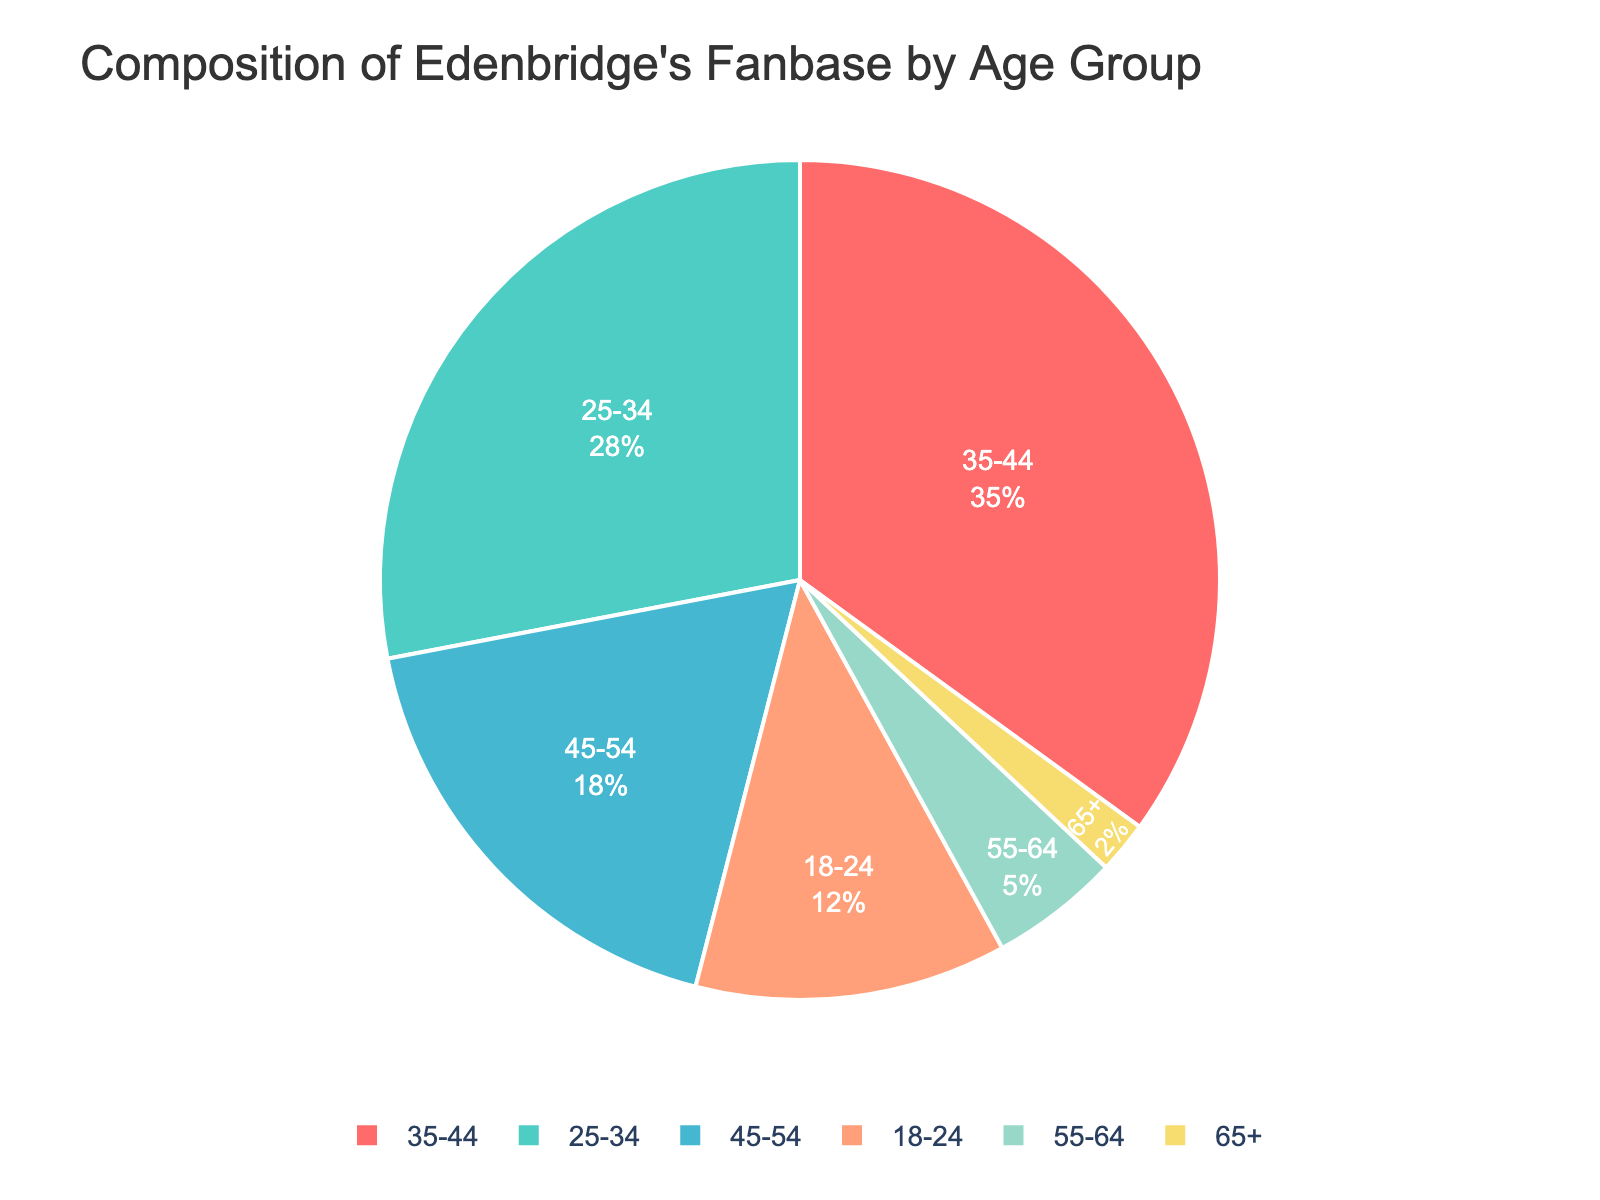What's the largest age group in Edenbridge's fanbase? Look at the pie chart and identify the sector with the largest percentage. The age group 35-44 has the largest percentage of 35%
Answer: Age group 35-44 What's the combined percentage of fans aged 45-64? Add the percentages for the age groups 45-54 and 55-64. Thus, 18% + 5% = 23%
Answer: 23% Which age group has the smallest representation in the fanbase? Look for the smallest sector in the pie chart representing the lowest percentage. The age group 65+ has the smallest percentage of 2%
Answer: Age group 65+ Is the percentage of the fanbase aged 25-34 higher than that of the 45-54 age group? Compare the percentages of the two age groups: 25-34 has 28%, and 45-54 has 18%. Since 28% > 18%, the 25-34 group is higher
Answer: Yes What's the difference in the percentage of fans between the 18-24 and the 55-64 age groups? Calculate the difference by subtracting the smaller percentage from the larger one: 12% (18-24) - 5% (55-64) = 7%
Answer: 7% What proportion of the fanbase is younger than 35? Add the percentages for the age groups 18-24 and 25-34: 12% + 28% = 40%
Answer: 40% How does the percentage of fans aged 35-44 compare to those aged 55+? Compare the percentage of the 35-44 age group (35%) to the sum of the percentages for 55-64 (5%) and 65+ (2%): 35% vs. (5% + 2%) = 7%. Thus, 35% is much higher
Answer: Much higher Which color represents the 25-34 age group in the pie chart? Find the color by looking at the legend or the sector corresponding to the 25-34 age group. In this pie chart, the 25-34 age group is represented by the second color in the custom palette, which is green (aqua)
Answer: Green (aqua) Is the percentage of fans in the oldest age group smaller than that in the youngest age group? Compare the percentages: 65+ has 2%, and 18-24 has 12%. Since 2% < 12%, the percentage in the oldest age group is smaller
Answer: Yes What's the second most common age group in Edenbridge's fanbase? Identify the second largest sector in the pie chart. The age group 25-34 has the second highest percentage of 28%
Answer: Age group 25-34 